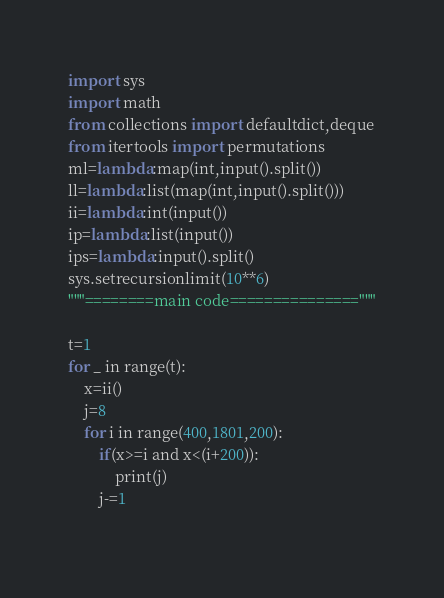<code> <loc_0><loc_0><loc_500><loc_500><_Python_>import sys
import math
from collections import defaultdict,deque
from itertools import permutations
ml=lambda:map(int,input().split())
ll=lambda:list(map(int,input().split()))
ii=lambda:int(input())
ip=lambda:list(input())
ips=lambda:input().split()
sys.setrecursionlimit(10**6)
"""========main code==============="""

t=1
for _ in range(t):
    x=ii()
    j=8
    for i in range(400,1801,200):
        if(x>=i and x<(i+200)):
            print(j)
        j-=1
        </code> 